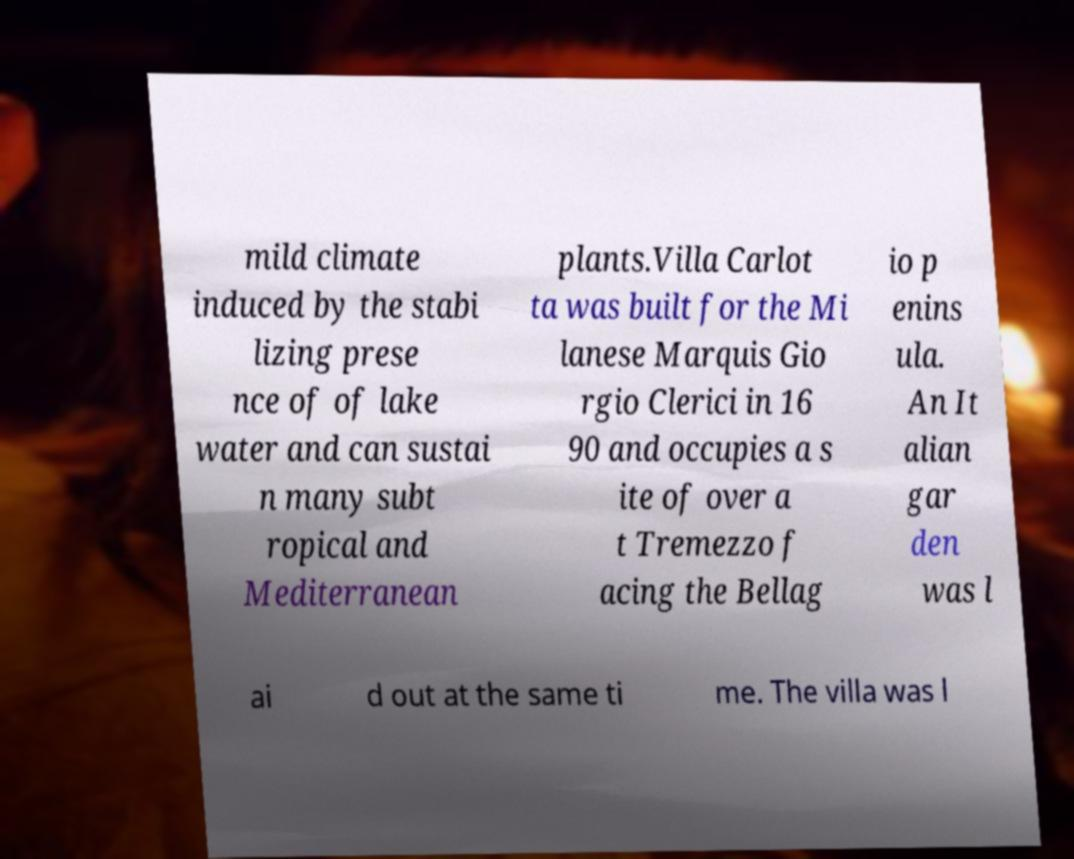There's text embedded in this image that I need extracted. Can you transcribe it verbatim? mild climate induced by the stabi lizing prese nce of of lake water and can sustai n many subt ropical and Mediterranean plants.Villa Carlot ta was built for the Mi lanese Marquis Gio rgio Clerici in 16 90 and occupies a s ite of over a t Tremezzo f acing the Bellag io p enins ula. An It alian gar den was l ai d out at the same ti me. The villa was l 